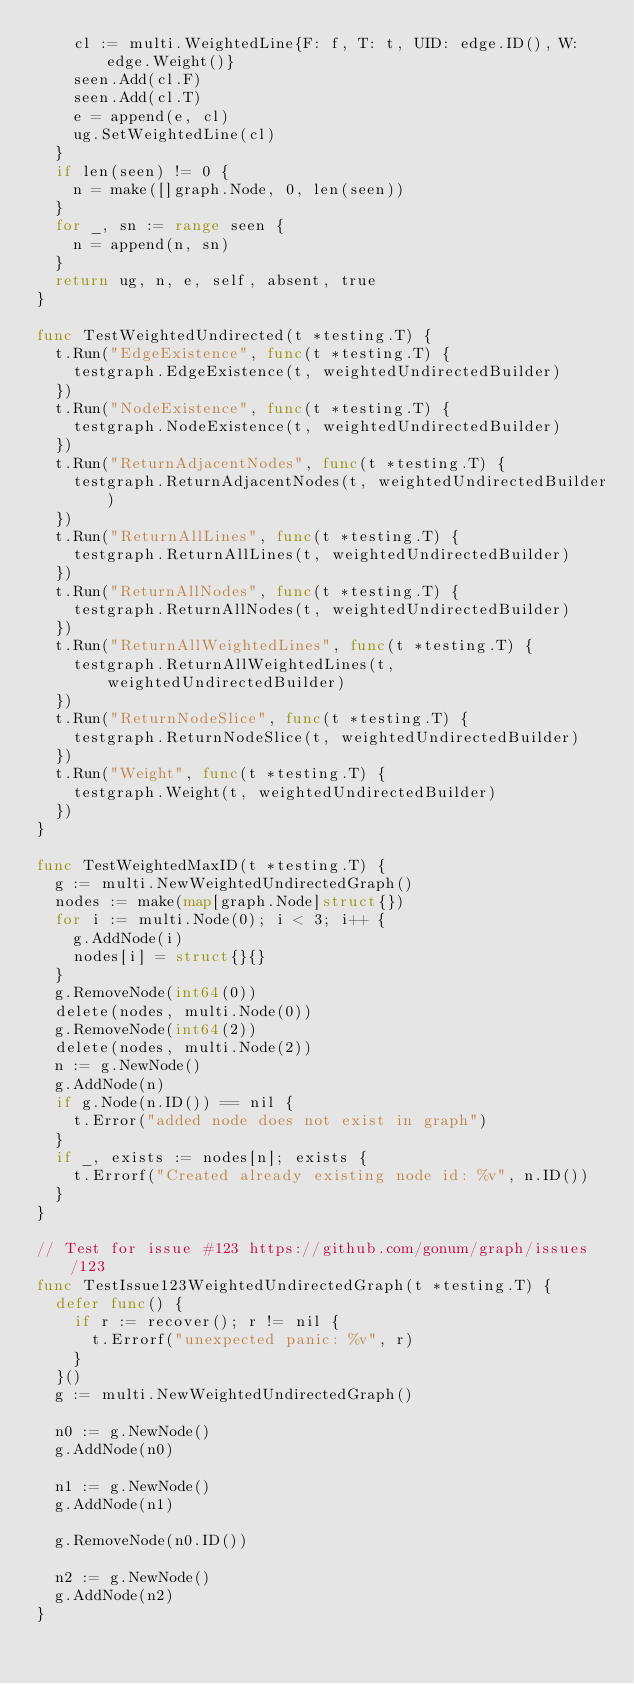<code> <loc_0><loc_0><loc_500><loc_500><_Go_>		cl := multi.WeightedLine{F: f, T: t, UID: edge.ID(), W: edge.Weight()}
		seen.Add(cl.F)
		seen.Add(cl.T)
		e = append(e, cl)
		ug.SetWeightedLine(cl)
	}
	if len(seen) != 0 {
		n = make([]graph.Node, 0, len(seen))
	}
	for _, sn := range seen {
		n = append(n, sn)
	}
	return ug, n, e, self, absent, true
}

func TestWeightedUndirected(t *testing.T) {
	t.Run("EdgeExistence", func(t *testing.T) {
		testgraph.EdgeExistence(t, weightedUndirectedBuilder)
	})
	t.Run("NodeExistence", func(t *testing.T) {
		testgraph.NodeExistence(t, weightedUndirectedBuilder)
	})
	t.Run("ReturnAdjacentNodes", func(t *testing.T) {
		testgraph.ReturnAdjacentNodes(t, weightedUndirectedBuilder)
	})
	t.Run("ReturnAllLines", func(t *testing.T) {
		testgraph.ReturnAllLines(t, weightedUndirectedBuilder)
	})
	t.Run("ReturnAllNodes", func(t *testing.T) {
		testgraph.ReturnAllNodes(t, weightedUndirectedBuilder)
	})
	t.Run("ReturnAllWeightedLines", func(t *testing.T) {
		testgraph.ReturnAllWeightedLines(t, weightedUndirectedBuilder)
	})
	t.Run("ReturnNodeSlice", func(t *testing.T) {
		testgraph.ReturnNodeSlice(t, weightedUndirectedBuilder)
	})
	t.Run("Weight", func(t *testing.T) {
		testgraph.Weight(t, weightedUndirectedBuilder)
	})
}

func TestWeightedMaxID(t *testing.T) {
	g := multi.NewWeightedUndirectedGraph()
	nodes := make(map[graph.Node]struct{})
	for i := multi.Node(0); i < 3; i++ {
		g.AddNode(i)
		nodes[i] = struct{}{}
	}
	g.RemoveNode(int64(0))
	delete(nodes, multi.Node(0))
	g.RemoveNode(int64(2))
	delete(nodes, multi.Node(2))
	n := g.NewNode()
	g.AddNode(n)
	if g.Node(n.ID()) == nil {
		t.Error("added node does not exist in graph")
	}
	if _, exists := nodes[n]; exists {
		t.Errorf("Created already existing node id: %v", n.ID())
	}
}

// Test for issue #123 https://github.com/gonum/graph/issues/123
func TestIssue123WeightedUndirectedGraph(t *testing.T) {
	defer func() {
		if r := recover(); r != nil {
			t.Errorf("unexpected panic: %v", r)
		}
	}()
	g := multi.NewWeightedUndirectedGraph()

	n0 := g.NewNode()
	g.AddNode(n0)

	n1 := g.NewNode()
	g.AddNode(n1)

	g.RemoveNode(n0.ID())

	n2 := g.NewNode()
	g.AddNode(n2)
}
</code> 